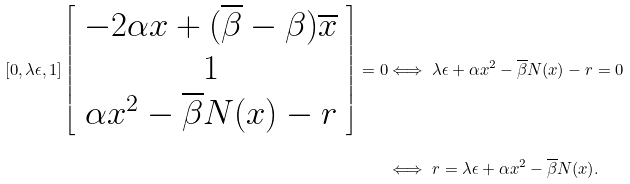Convert formula to latex. <formula><loc_0><loc_0><loc_500><loc_500>[ 0 , \lambda \epsilon , 1 ] \left [ \begin{array} { c } - 2 \alpha x + ( \overline { \beta } - \beta ) \overline { x } \\ 1 \\ \alpha x ^ { 2 } - \overline { \beta } N ( x ) - r \end{array} \right ] = 0 & \Longleftrightarrow \ \lambda \epsilon + \alpha x ^ { 2 } - \overline { \beta } N ( x ) - r = 0 \\ & \Longleftrightarrow \ r = \lambda \epsilon + \alpha x ^ { 2 } - \overline { \beta } N ( x ) .</formula> 